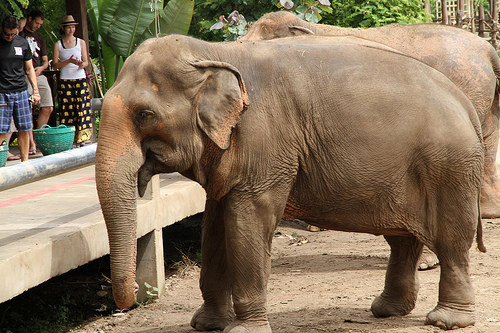What is in front of the large animal? There is a floor in front of the large animal, which is an elephant. 